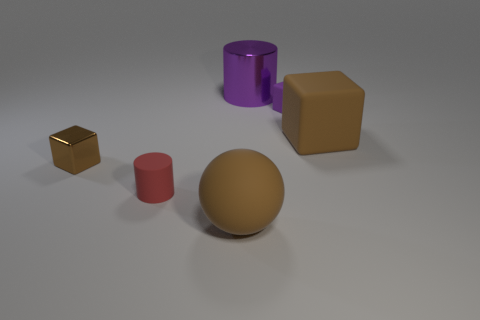What number of other purple objects are the same shape as the purple rubber object?
Offer a terse response. 0. How many tiny rubber objects are to the left of the large thing that is in front of the tiny red object?
Provide a succinct answer. 1. How many matte objects are either purple cylinders or cubes?
Provide a succinct answer. 2. Is there a gray cube made of the same material as the brown sphere?
Make the answer very short. No. What number of objects are either brown blocks that are left of the big matte block or tiny matte objects that are on the right side of the brown shiny cube?
Provide a short and direct response. 3. There is a block to the left of the tiny purple object; is its color the same as the metallic cylinder?
Provide a succinct answer. No. How many other objects are there of the same color as the sphere?
Keep it short and to the point. 2. What is the purple cube made of?
Give a very brief answer. Rubber. Do the brown matte object that is in front of the brown shiny cube and the large brown block have the same size?
Offer a terse response. Yes. Are there any other things that have the same size as the purple rubber block?
Ensure brevity in your answer.  Yes. 